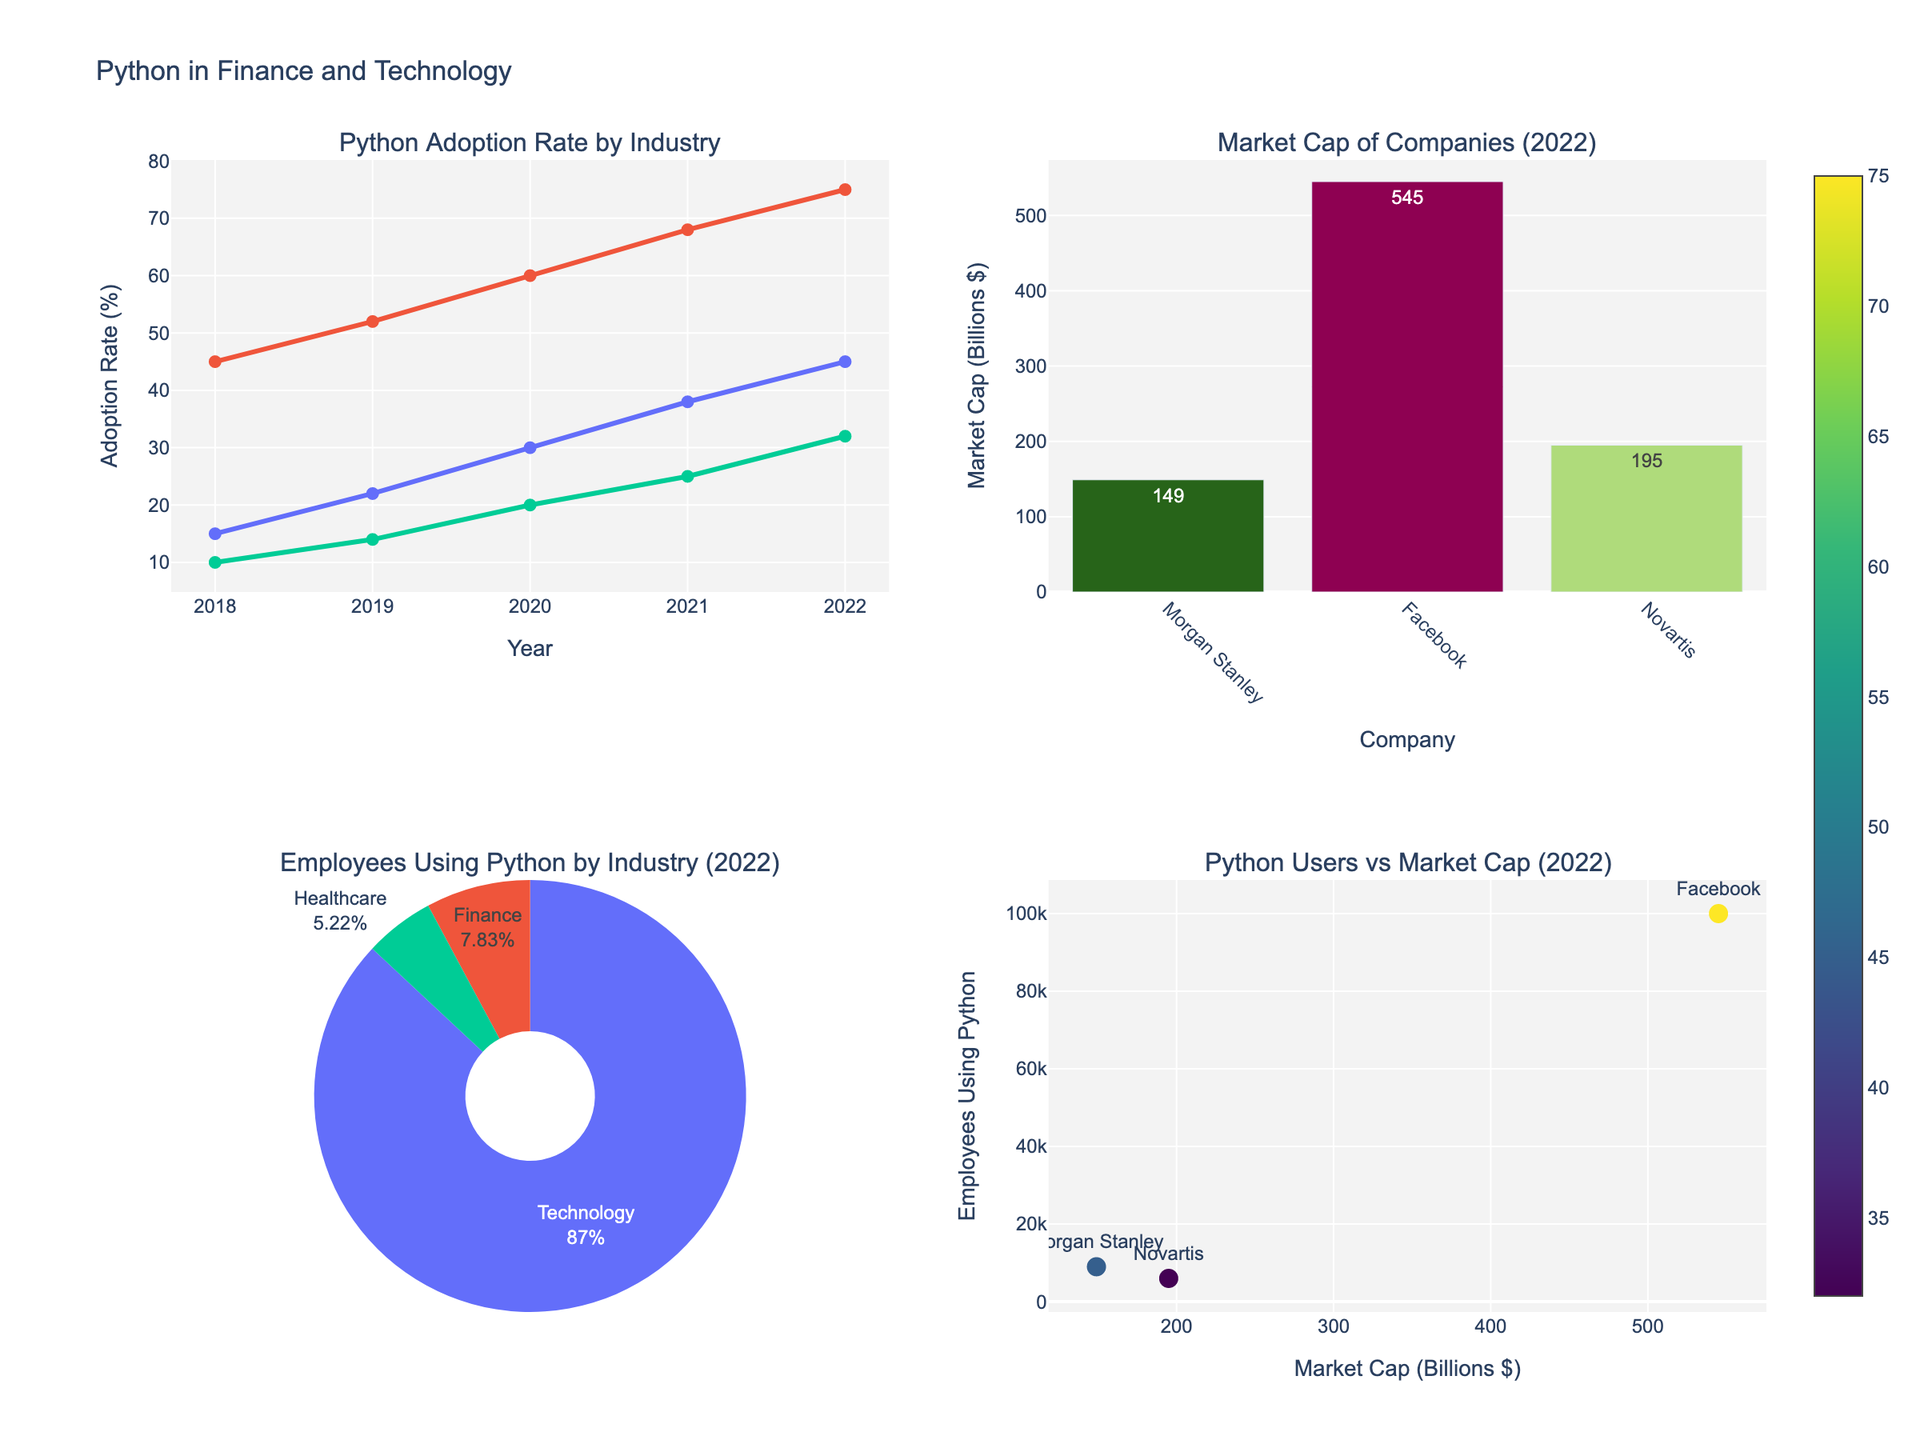what's the title of the figure? The title of the figure is typically located at the top center of the plot area, summarizing the content. From the provided code, the title is composed using the "update_layout" function.
Answer: "Python in Finance and Technology" Which industry had the highest Python adoption rate in 2022? From the subplot "Python Adoption Rate by Industry," observe the rightmost data points. The technology sector has the highest point, indicating the highest adoption rate.
Answer: Technology How many employees in the finance sector used Python in 2022? Refer to the "Employees Using Python by Industry (2022)" pie chart, hover over the finance sector for the exact value or deduce from the slice size.
Answer: 9,000 Compare the market cap of Amazon and Facebook in 2022. Which company has a higher market cap? Refer to the "Market Cap of Companies (2022)" bar chart and compare the heights of the bars for Amazon and Facebook. Amazon's bar is significantly higher.
Answer: Amazon What is the percentage of employees using Python in the Technology sector in 2022? Refer to the "Employees Using Python by Industry (2022)" pie chart. The technology sector slice and its percentage can be seen by hovering or is the largest segment visually.
Answer: Largest percentage What trend do you see in the adoption rate for the Finance sector from 2018 to 2022? Follow the line in the "Python Adoption Rate by Industry" scatter plot for the Finance sector. Each year's point increases steadily.
Answer: Increasing trend What is the market cap difference between Google and Microsoft in 2022? Refer to the "Market Cap of Companies (2022)" bar chart and subtract the height of Google's bar from Microsoft's bar. Microsoft $1,070B - Google $730B.
Answer: $340B How does the number of employees using Python in the Healthcare sector compare to the Finance sector in 2022? Refer to the "Employees Using Python by Industry (2022)" pie chart. The size of the Healthcare slice is smaller than that of Finance.
Answer: Healthcare less Which company in 2022 has the highest adoption rate of Python and what is it? Refer to the "Python Users vs Market Cap (2022)" scatter plot. The highest adoption rate will be indicated by the most intense marker color, which is Facebook with 75%.
Answer: Facebook, 75% 